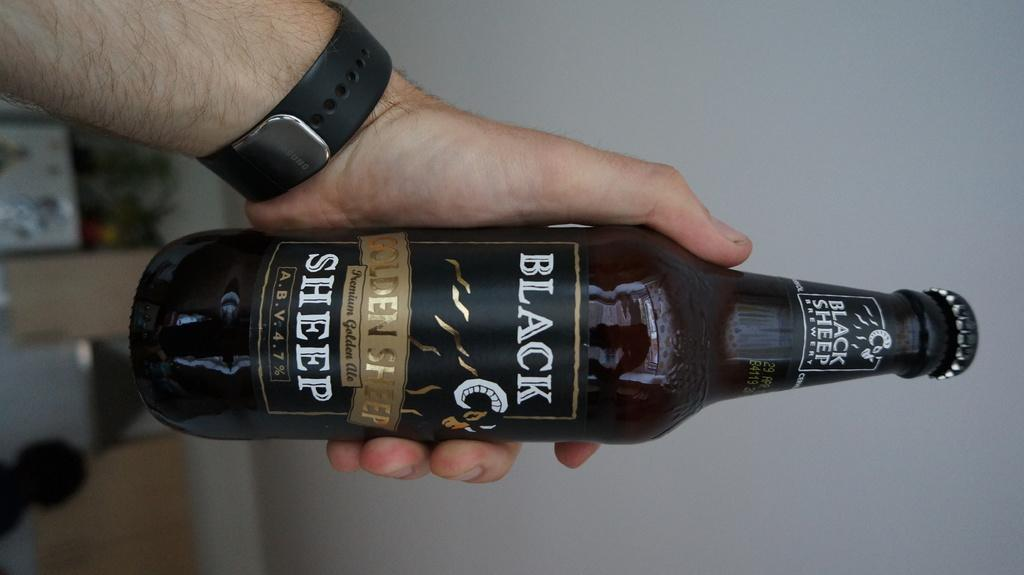<image>
Present a compact description of the photo's key features. Person holding a beer can which says Black Sheep on it. 